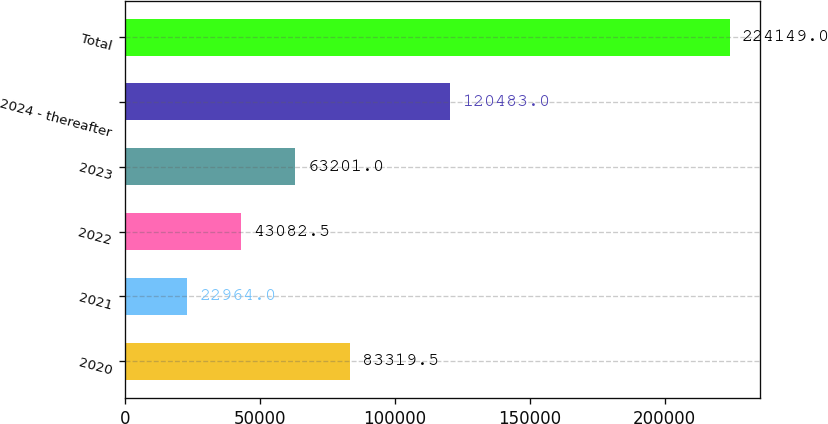<chart> <loc_0><loc_0><loc_500><loc_500><bar_chart><fcel>2020<fcel>2021<fcel>2022<fcel>2023<fcel>2024 - thereafter<fcel>Total<nl><fcel>83319.5<fcel>22964<fcel>43082.5<fcel>63201<fcel>120483<fcel>224149<nl></chart> 